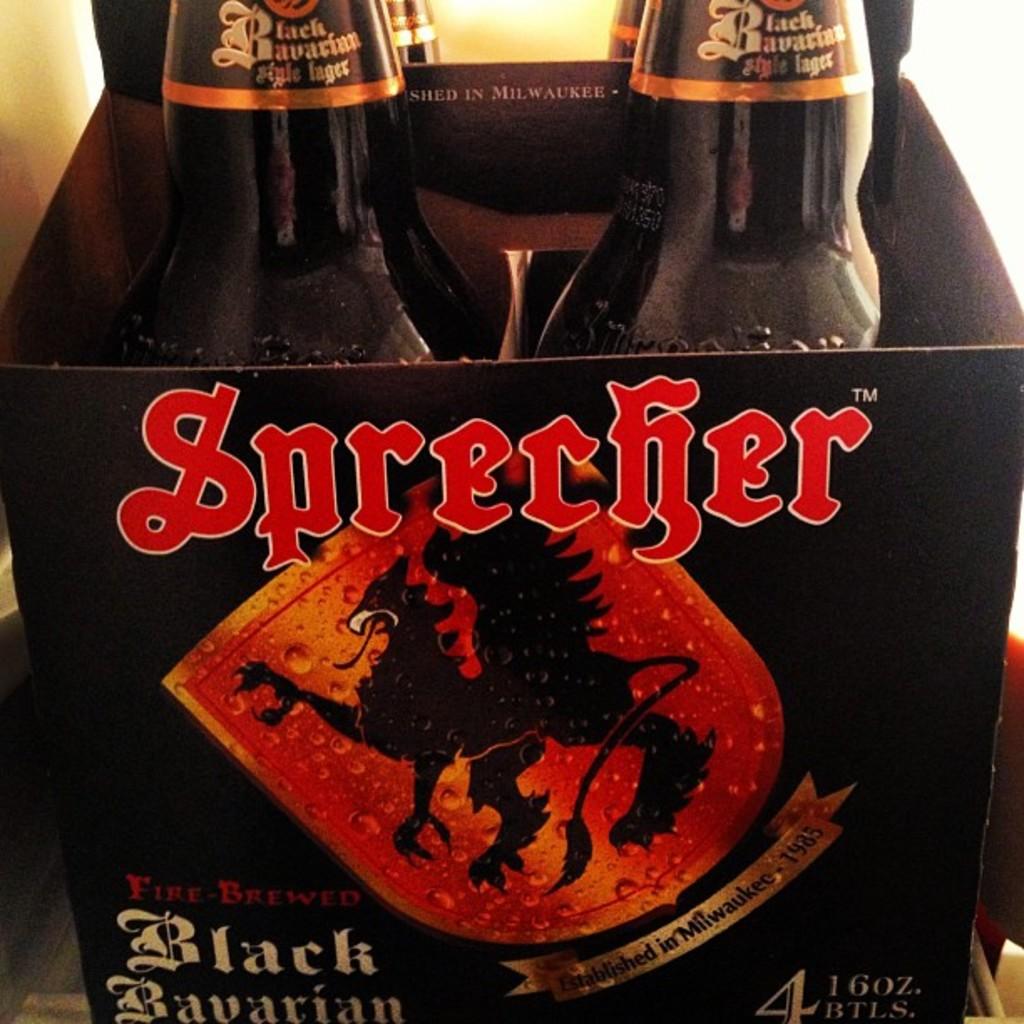What brand of beer is this?
Your answer should be very brief. Sprecher. 